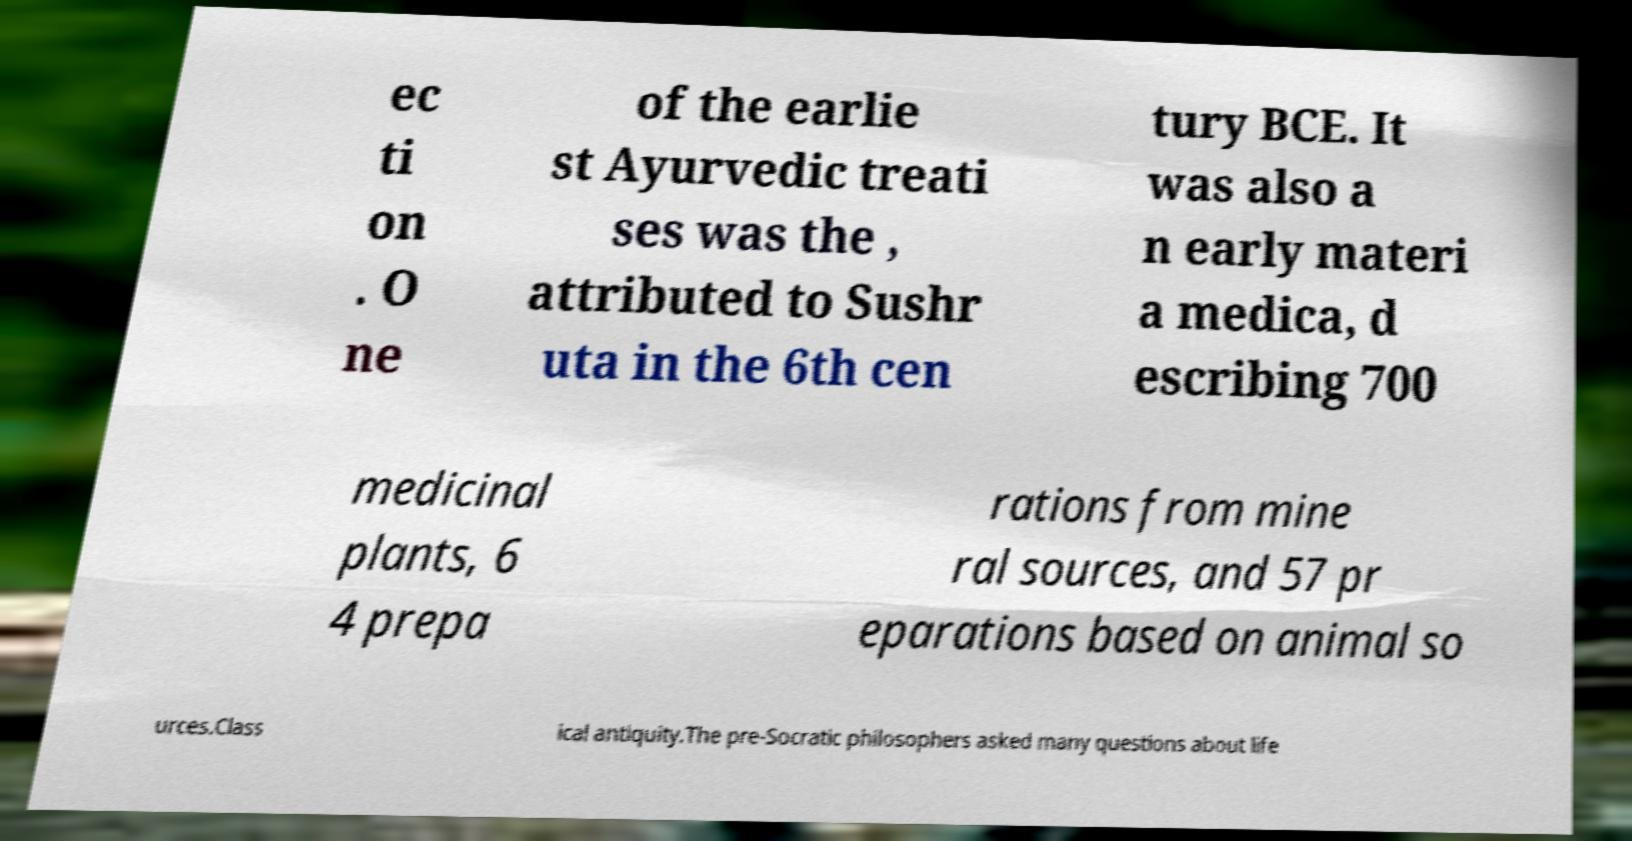What messages or text are displayed in this image? I need them in a readable, typed format. ec ti on . O ne of the earlie st Ayurvedic treati ses was the , attributed to Sushr uta in the 6th cen tury BCE. It was also a n early materi a medica, d escribing 700 medicinal plants, 6 4 prepa rations from mine ral sources, and 57 pr eparations based on animal so urces.Class ical antiquity.The pre-Socratic philosophers asked many questions about life 